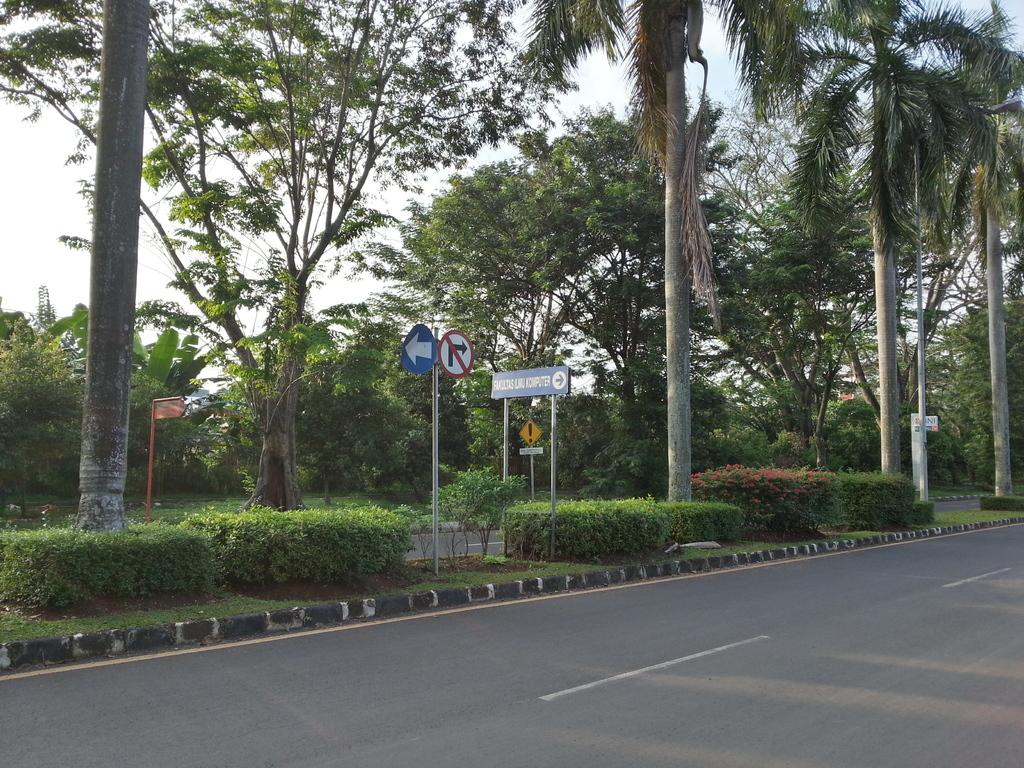What is the main feature of the image? There is a road in the image. What can be seen behind the road? There are bushes behind the road. What is located behind the bushes? There are trees behind the bushes. What type of lighting is present in the image? A street light is present in the image. What are the boards attached to in the image? The boards are attached to poles in the image. What is visible in the background of the image? The sky is visible behind the trees. Can you tell me how many beggars are visible in the image? There are no beggars present in the image. What type of wilderness can be seen in the background of the image? There is no wilderness visible in the image; it features a road, bushes, trees, and a street light. 